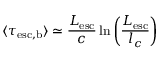<formula> <loc_0><loc_0><loc_500><loc_500>\langle \tau _ { e s c , b } \rangle \simeq \frac { L _ { e s c } } { c } \ln { \left ( \frac { L _ { e s c } } { l _ { c } } \right ) }</formula> 